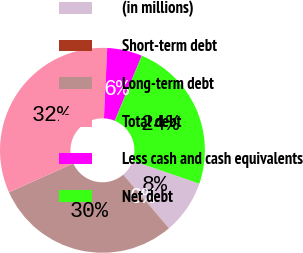Convert chart to OTSL. <chart><loc_0><loc_0><loc_500><loc_500><pie_chart><fcel>(in millions)<fcel>Short-term debt<fcel>Long-term debt<fcel>Total debt<fcel>Less cash and cash equivalents<fcel>Net debt<nl><fcel>8.48%<fcel>0.02%<fcel>29.51%<fcel>32.46%<fcel>5.53%<fcel>24.0%<nl></chart> 